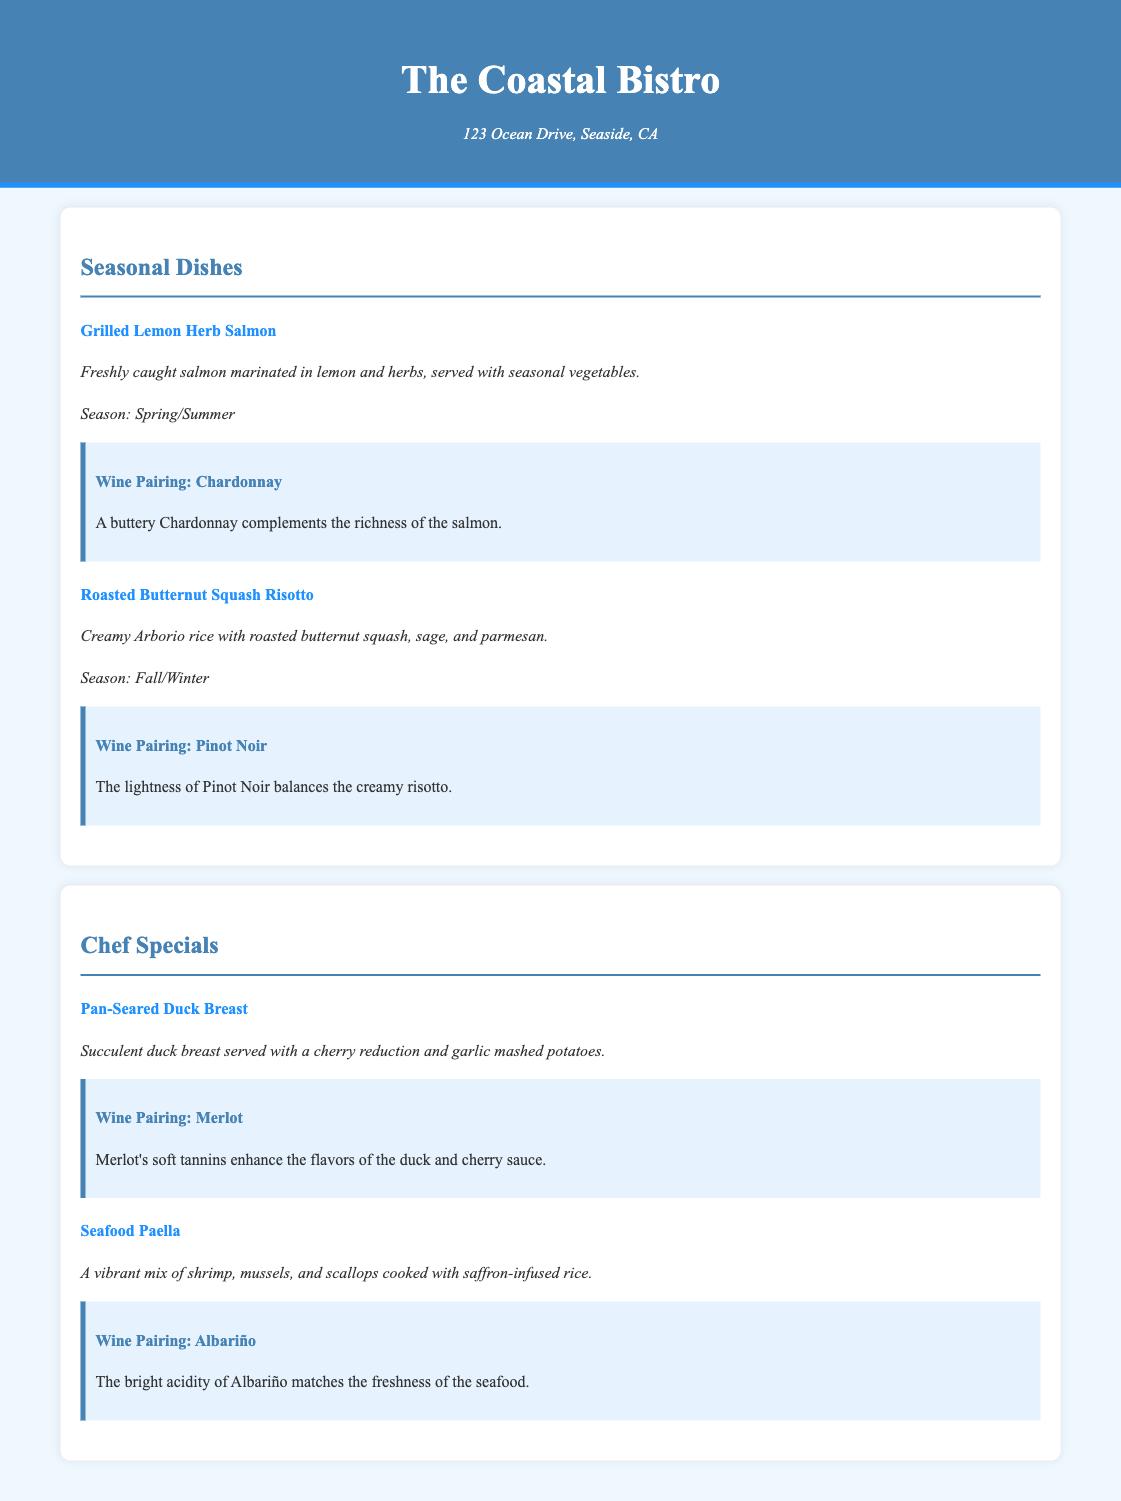what is the name of the restaurant? The restaurant name is prominently displayed in the header of the document.
Answer: The Coastal Bistro where is the restaurant located? The location of the restaurant is provided under the restaurant name in the header.
Answer: 123 Ocean Drive, Seaside, CA what dish is available in spring/summer? The seasonal dishes section lists dishes along with their available seasons.
Answer: Grilled Lemon Herb Salmon what is the wine pairing for the Roasted Butternut Squash Risotto? The wine pairing section for each dish specifies the recommended wine for that particular dish.
Answer: Pinot Noir what is the main ingredient in the Seafood Paella? The dish description of the Seafood Paella outlines its main components.
Answer: shrimp, mussels, scallops which chef special is served with cherry reduction? The chef specials section describes each special and their accompaniments.
Answer: Pan-Seared Duck Breast what season is the Roasted Butternut Squash Risotto served? Each dish in the seasonal dishes includes the season it is served.
Answer: Fall/Winter what type of rice is used in the risotto? The description of the Roasted Butternut Squash Risotto lists the type of rice used in this dish.
Answer: Arborio rice what is the color of the header background? The header background color is defined in the style section of the document.
Answer: #4682b4 